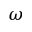<formula> <loc_0><loc_0><loc_500><loc_500>\omega</formula> 